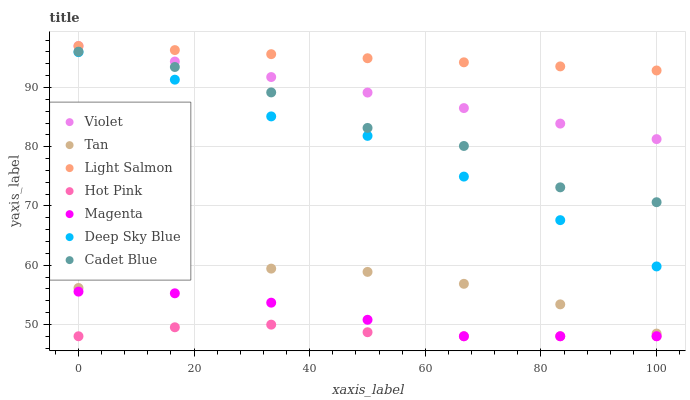Does Hot Pink have the minimum area under the curve?
Answer yes or no. Yes. Does Light Salmon have the maximum area under the curve?
Answer yes or no. Yes. Does Cadet Blue have the minimum area under the curve?
Answer yes or no. No. Does Cadet Blue have the maximum area under the curve?
Answer yes or no. No. Is Light Salmon the smoothest?
Answer yes or no. Yes. Is Cadet Blue the roughest?
Answer yes or no. Yes. Is Hot Pink the smoothest?
Answer yes or no. No. Is Hot Pink the roughest?
Answer yes or no. No. Does Hot Pink have the lowest value?
Answer yes or no. Yes. Does Cadet Blue have the lowest value?
Answer yes or no. No. Does Violet have the highest value?
Answer yes or no. Yes. Does Cadet Blue have the highest value?
Answer yes or no. No. Is Tan less than Violet?
Answer yes or no. Yes. Is Tan greater than Hot Pink?
Answer yes or no. Yes. Does Violet intersect Light Salmon?
Answer yes or no. Yes. Is Violet less than Light Salmon?
Answer yes or no. No. Is Violet greater than Light Salmon?
Answer yes or no. No. Does Tan intersect Violet?
Answer yes or no. No. 